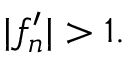<formula> <loc_0><loc_0><loc_500><loc_500>| f _ { n } ^ { \prime } | > 1 .</formula> 